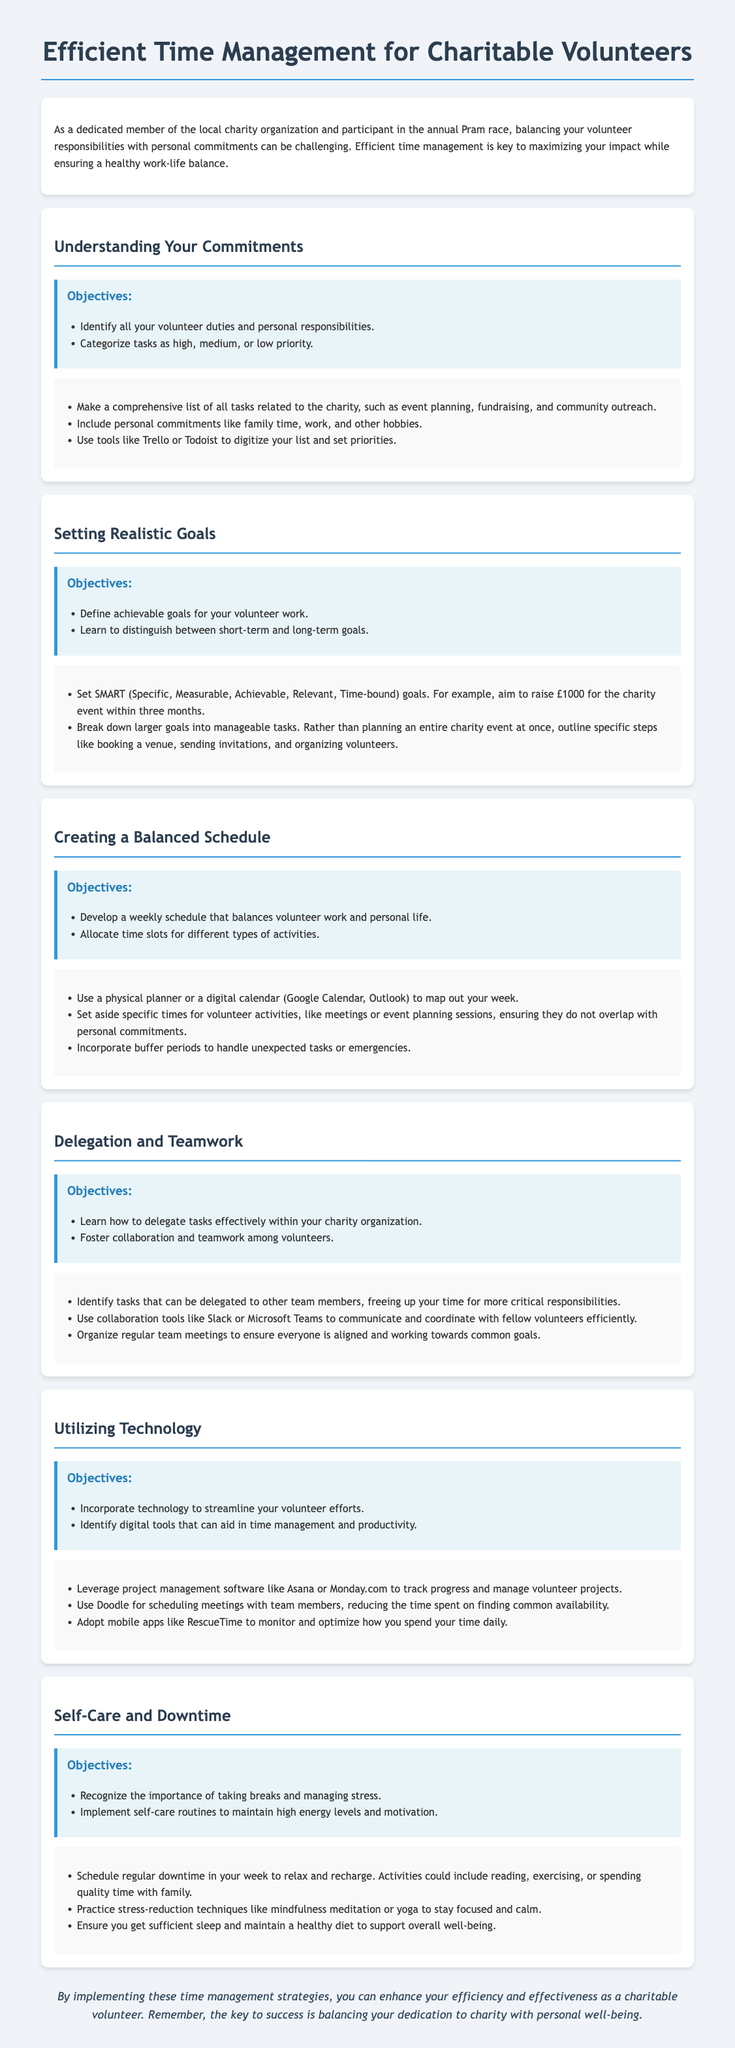what is the title of the lesson plan? The title of the lesson plan is found at the top of the document.
Answer: Efficient Time Management for Charitable Volunteers what is one of the key objectives under "Understanding Your Commitments"? Key objectives in that section include identifying all volunteer duties and personal responsibilities.
Answer: Identify all your volunteer duties and personal responsibilities what is the SMART goal example mentioned for fundraising? The document provides a specific fundraising goal as an example of a SMART goal.
Answer: Raise £1000 for the charity event within three months how can you categorize tasks in the document? The lesson plan suggests categorizing tasks into specific priority levels.
Answer: High, medium, or low priority what tool can be used for scheduling meetings? The document lists a specific tool for scheduling meetings among team members.
Answer: Doodle how does the lesson suggest handling unexpected tasks? The lesson explains the importance of specific scheduling practices to manage unexpected tasks.
Answer: Incorporate buffer periods name one technology suggested for tracking volunteer projects. The lesson plan mentions various types of software for project management.
Answer: Asana what should be included in a balanced schedule according to the document? The section on scheduling emphasizes the allocation of specific time slots for different activities.
Answer: Time slots for different types of activities what is emphasized as important for personal well-being? The lesson highlights a specific aspect of self-care that contributes to overall well-being.
Answer: Taking breaks 